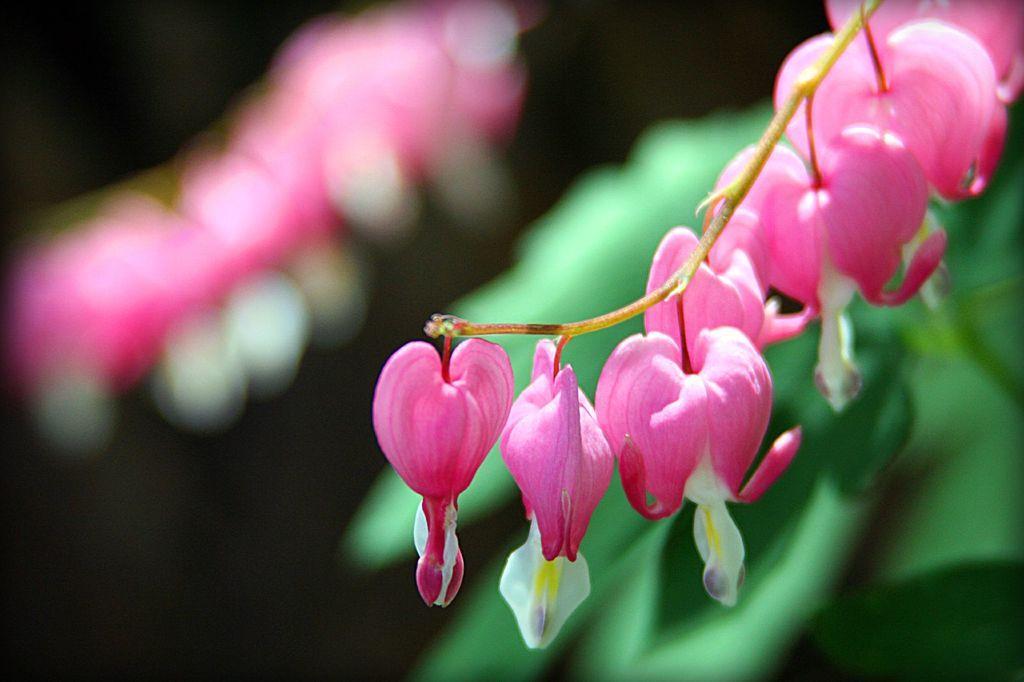Could you give a brief overview of what you see in this image? In this image I can see the pink and white color flowers. Background is in green, pink, white and black color. 